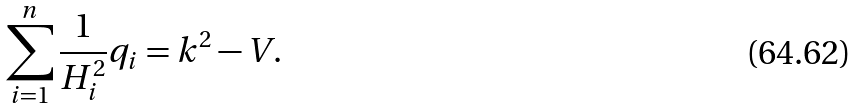Convert formula to latex. <formula><loc_0><loc_0><loc_500><loc_500>\sum _ { i = 1 } ^ { n } \frac { 1 } { H _ { i } ^ { 2 } } q _ { i } = k ^ { 2 } - V .</formula> 